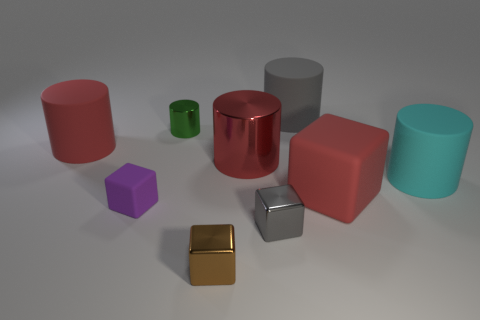Subtract 2 cylinders. How many cylinders are left? 3 Subtract all blue cylinders. Subtract all blue spheres. How many cylinders are left? 5 Add 1 tiny metal things. How many objects exist? 10 Subtract all cylinders. How many objects are left? 4 Subtract all tiny matte spheres. Subtract all tiny green shiny objects. How many objects are left? 8 Add 6 tiny rubber cubes. How many tiny rubber cubes are left? 7 Add 5 cyan metallic cylinders. How many cyan metallic cylinders exist? 5 Subtract 0 brown cylinders. How many objects are left? 9 